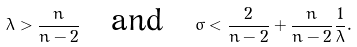<formula> <loc_0><loc_0><loc_500><loc_500>\lambda > \frac { n } { n - 2 } \quad \text {and} \quad \sigma < \frac { 2 } { n - 2 } + \frac { n } { n - 2 } \frac { 1 } { \lambda } .</formula> 